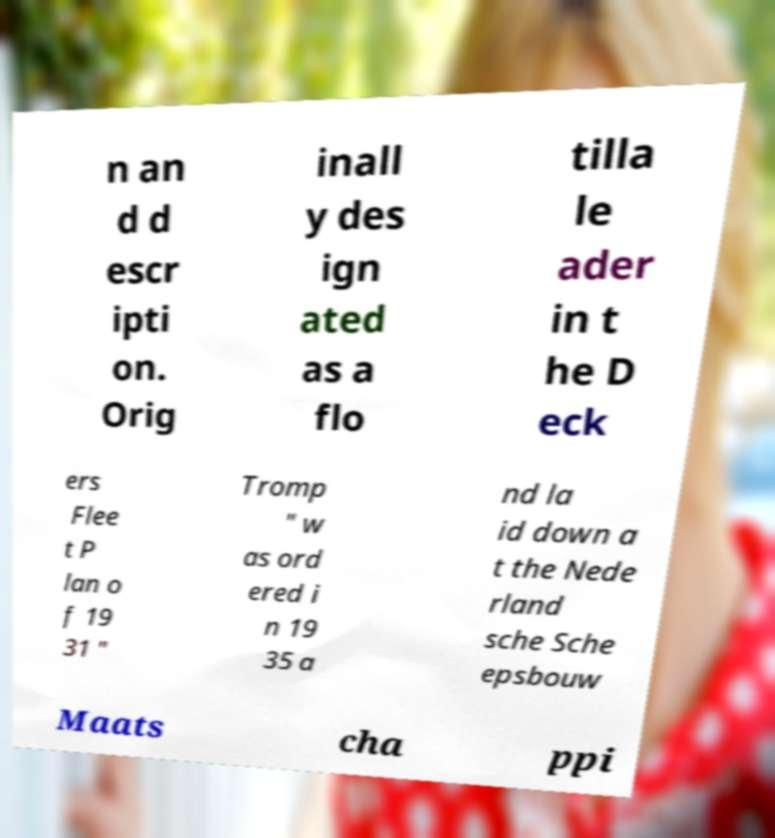I need the written content from this picture converted into text. Can you do that? n an d d escr ipti on. Orig inall y des ign ated as a flo tilla le ader in t he D eck ers Flee t P lan o f 19 31 " Tromp " w as ord ered i n 19 35 a nd la id down a t the Nede rland sche Sche epsbouw Maats cha ppi 